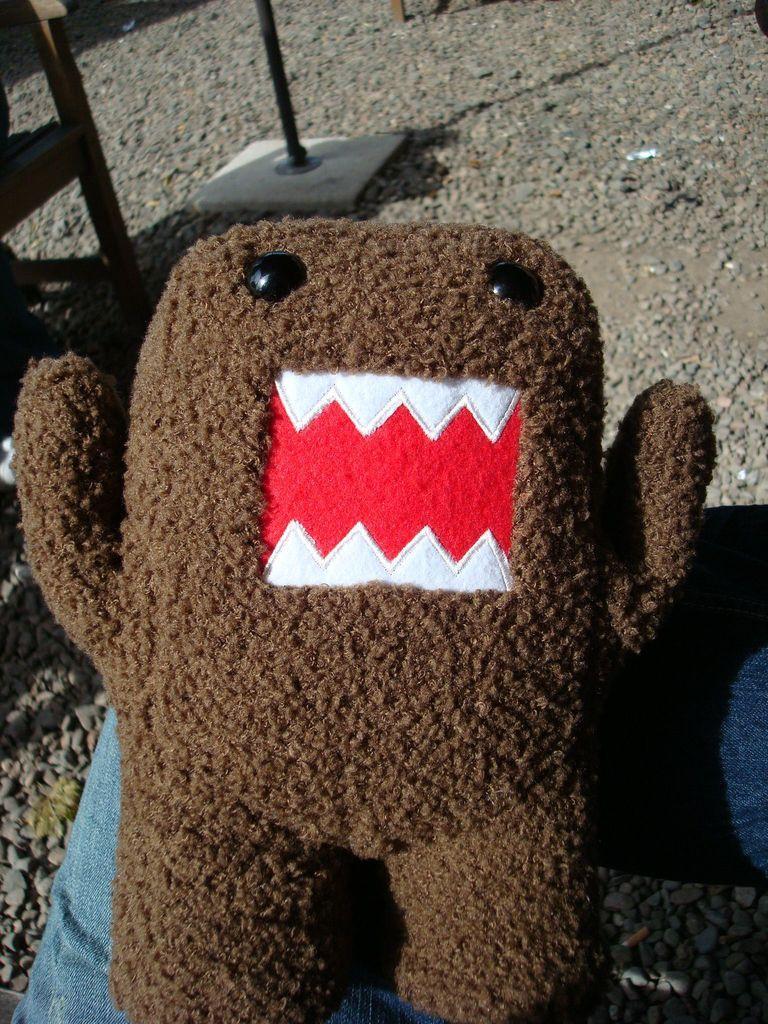How would you summarize this image in a sentence or two? In the image there is a toy which is in brown, red and white color. And its eyes are in black color. The toy is on the person leg. In the background there is a pole, chair and also there are few stones on the ground. 